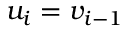Convert formula to latex. <formula><loc_0><loc_0><loc_500><loc_500>u _ { i } = v _ { i - 1 }</formula> 